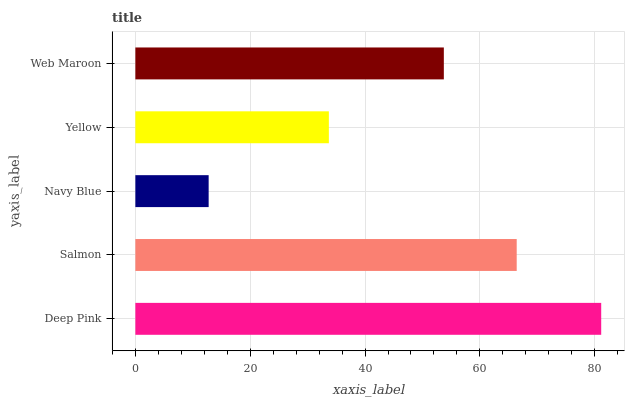Is Navy Blue the minimum?
Answer yes or no. Yes. Is Deep Pink the maximum?
Answer yes or no. Yes. Is Salmon the minimum?
Answer yes or no. No. Is Salmon the maximum?
Answer yes or no. No. Is Deep Pink greater than Salmon?
Answer yes or no. Yes. Is Salmon less than Deep Pink?
Answer yes or no. Yes. Is Salmon greater than Deep Pink?
Answer yes or no. No. Is Deep Pink less than Salmon?
Answer yes or no. No. Is Web Maroon the high median?
Answer yes or no. Yes. Is Web Maroon the low median?
Answer yes or no. Yes. Is Navy Blue the high median?
Answer yes or no. No. Is Yellow the low median?
Answer yes or no. No. 